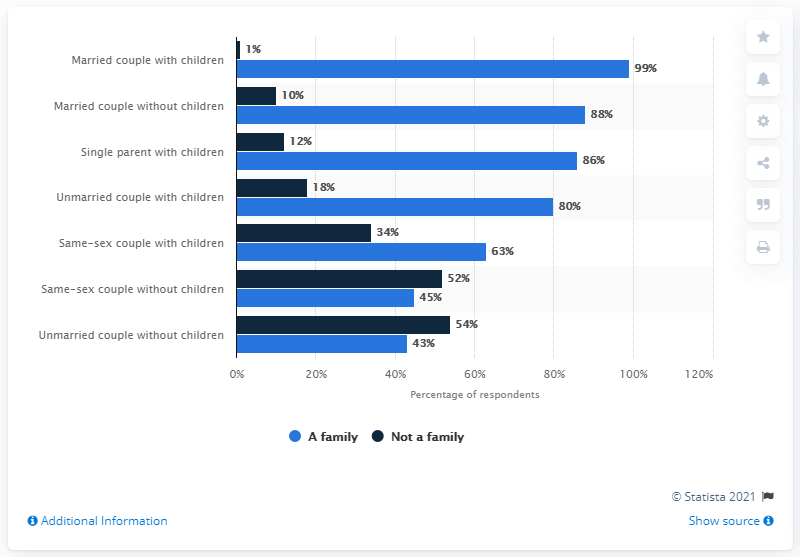Outline some significant characteristics in this image. The chart shows that the value of a family is continuously increasing, with a downward trend. According to the survey, 86% of single parents with children expressed a desire to form a family. 